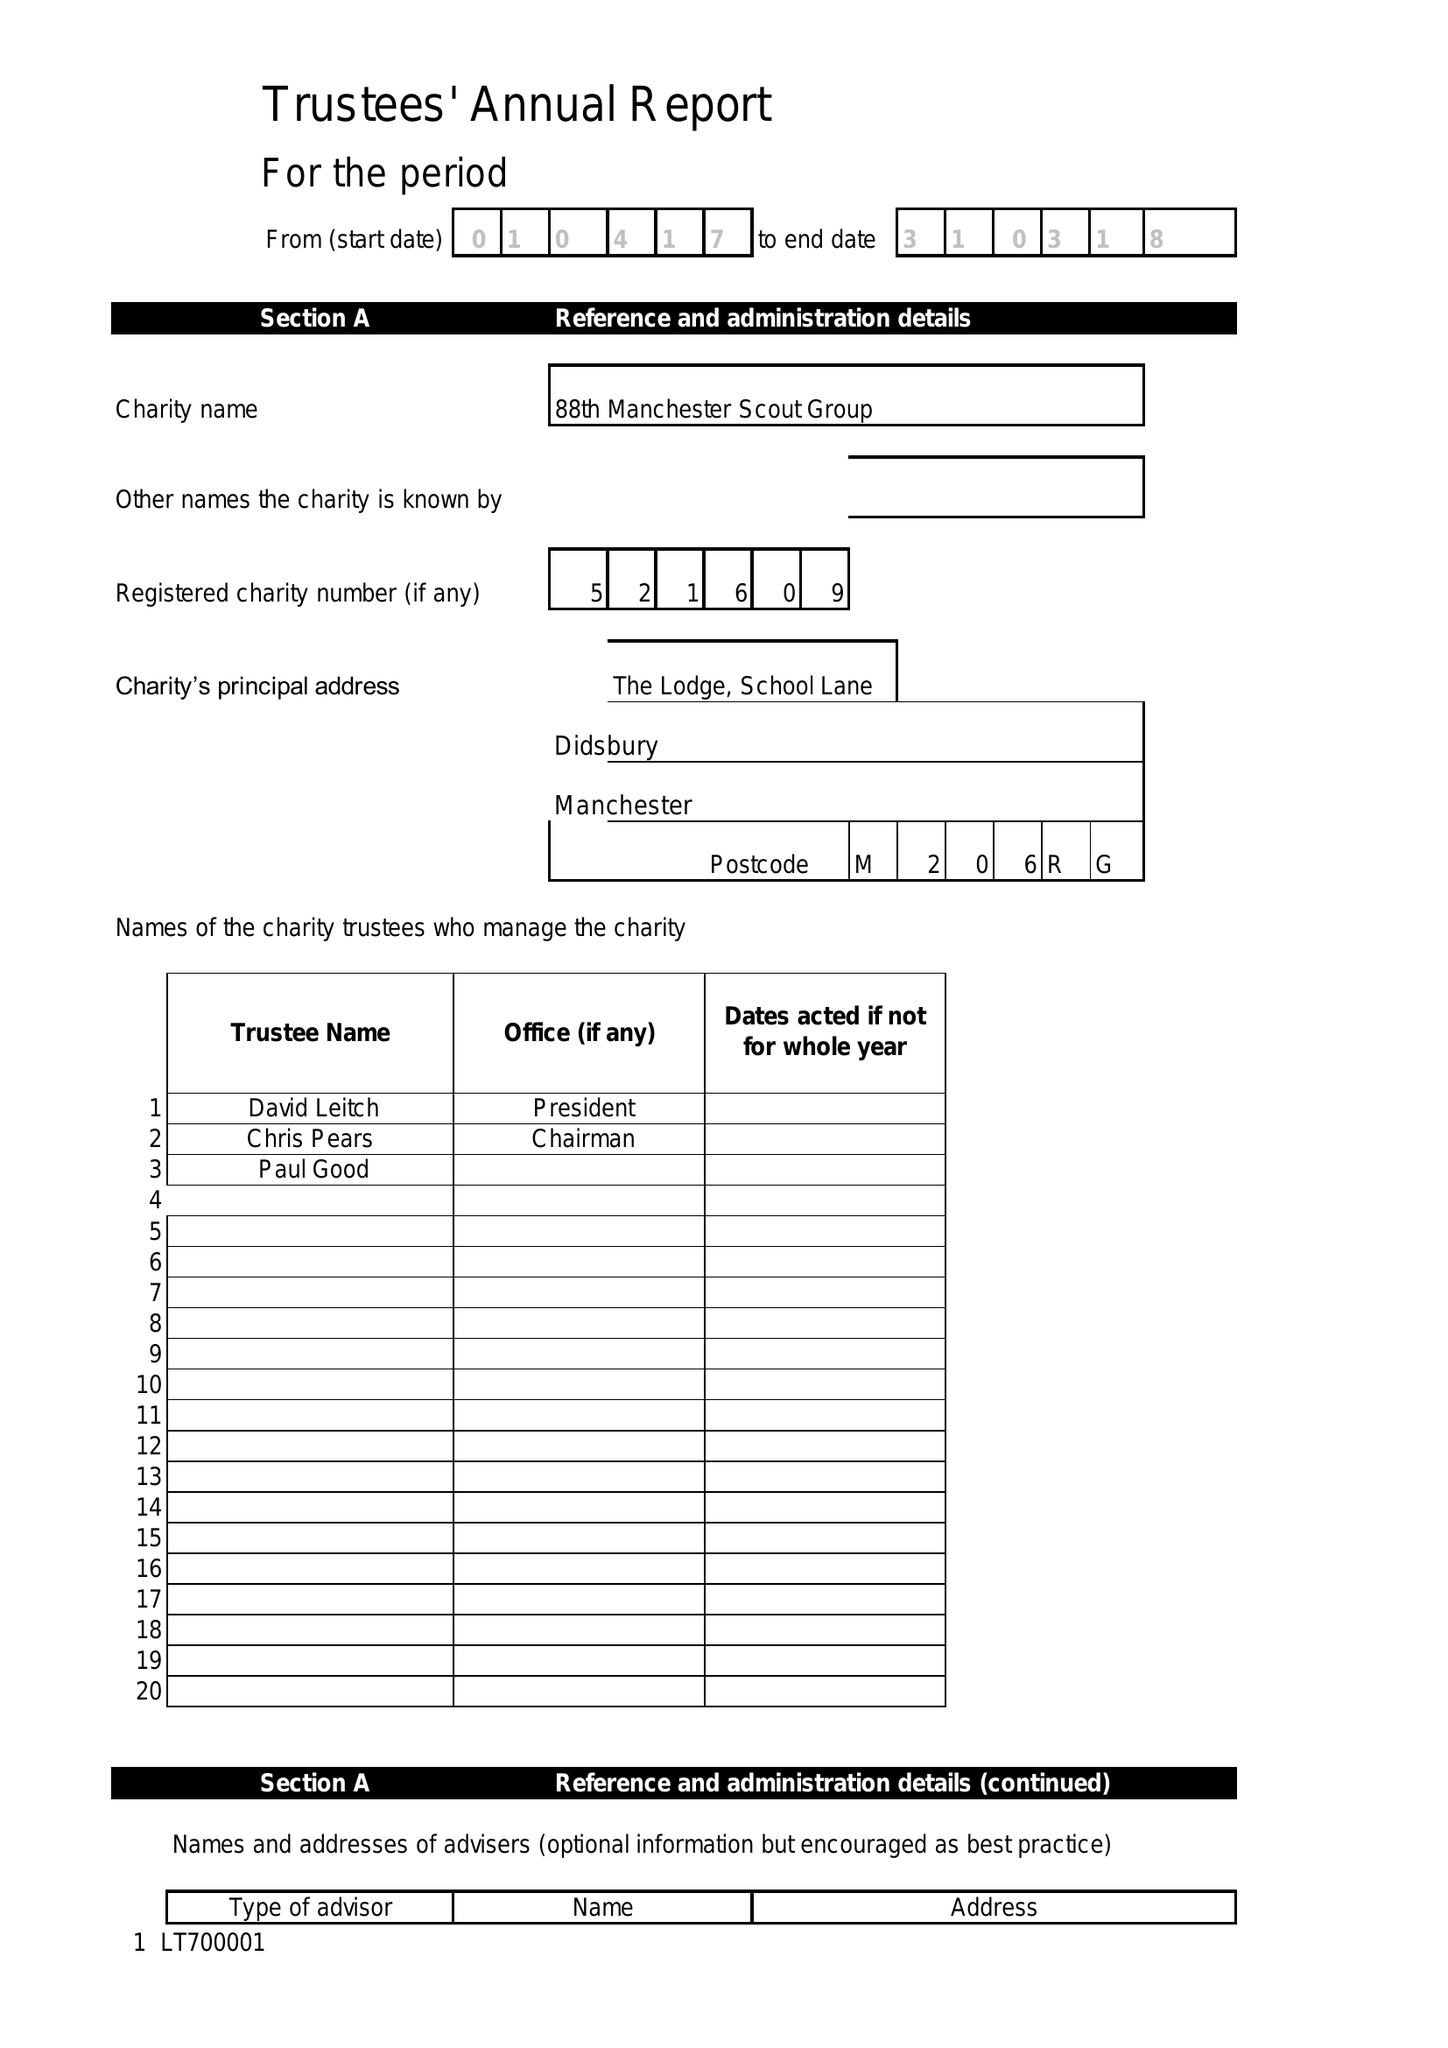What is the value for the address__postcode?
Answer the question using a single word or phrase. SK4 4BX 